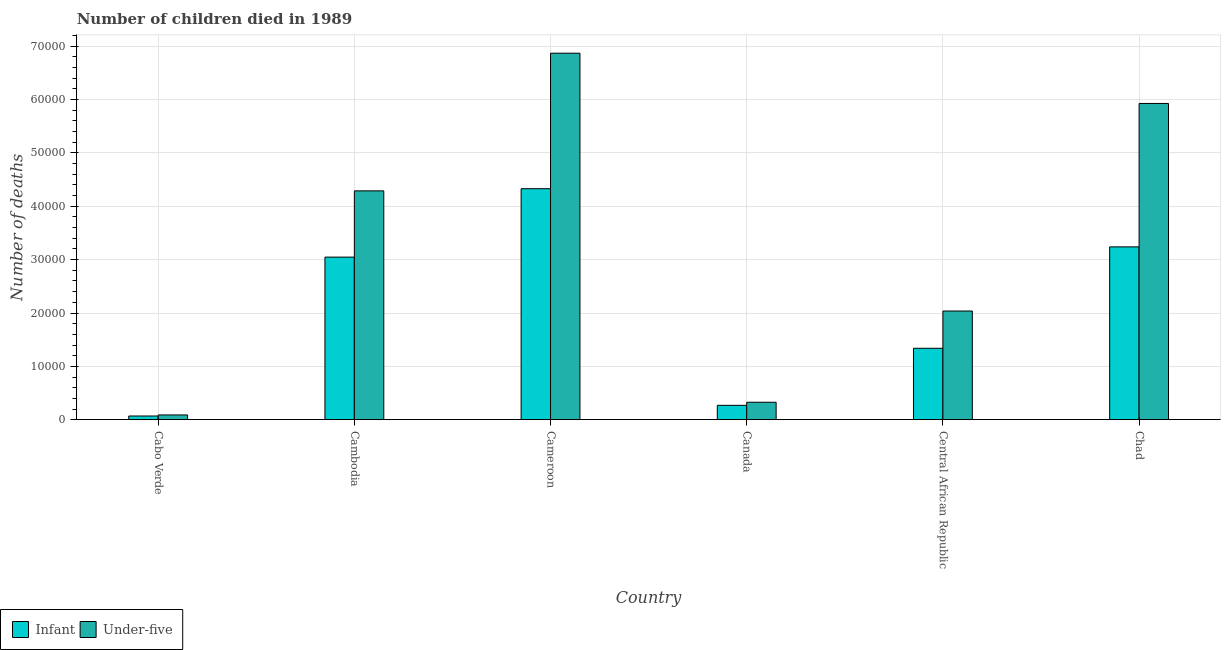How many different coloured bars are there?
Your response must be concise. 2. Are the number of bars per tick equal to the number of legend labels?
Provide a short and direct response. Yes. How many bars are there on the 2nd tick from the left?
Ensure brevity in your answer.  2. How many bars are there on the 2nd tick from the right?
Give a very brief answer. 2. What is the label of the 2nd group of bars from the left?
Your answer should be very brief. Cambodia. In how many cases, is the number of bars for a given country not equal to the number of legend labels?
Make the answer very short. 0. What is the number of under-five deaths in Central African Republic?
Ensure brevity in your answer.  2.04e+04. Across all countries, what is the maximum number of infant deaths?
Your response must be concise. 4.33e+04. Across all countries, what is the minimum number of infant deaths?
Give a very brief answer. 691. In which country was the number of under-five deaths maximum?
Provide a short and direct response. Cameroon. In which country was the number of infant deaths minimum?
Your response must be concise. Cabo Verde. What is the total number of infant deaths in the graph?
Your response must be concise. 1.23e+05. What is the difference between the number of under-five deaths in Canada and that in Chad?
Your response must be concise. -5.60e+04. What is the difference between the number of infant deaths in Chad and the number of under-five deaths in Cabo Verde?
Your response must be concise. 3.15e+04. What is the average number of under-five deaths per country?
Provide a succinct answer. 3.26e+04. What is the difference between the number of infant deaths and number of under-five deaths in Chad?
Your response must be concise. -2.69e+04. What is the ratio of the number of infant deaths in Cambodia to that in Central African Republic?
Ensure brevity in your answer.  2.28. Is the number of infant deaths in Cambodia less than that in Canada?
Ensure brevity in your answer.  No. What is the difference between the highest and the second highest number of infant deaths?
Provide a succinct answer. 1.09e+04. What is the difference between the highest and the lowest number of infant deaths?
Give a very brief answer. 4.26e+04. In how many countries, is the number of infant deaths greater than the average number of infant deaths taken over all countries?
Provide a short and direct response. 3. What does the 1st bar from the left in Cameroon represents?
Offer a very short reply. Infant. What does the 1st bar from the right in Canada represents?
Provide a succinct answer. Under-five. Are all the bars in the graph horizontal?
Ensure brevity in your answer.  No. How many countries are there in the graph?
Your answer should be compact. 6. What is the difference between two consecutive major ticks on the Y-axis?
Provide a succinct answer. 10000. Are the values on the major ticks of Y-axis written in scientific E-notation?
Give a very brief answer. No. Where does the legend appear in the graph?
Your answer should be compact. Bottom left. How are the legend labels stacked?
Provide a short and direct response. Horizontal. What is the title of the graph?
Make the answer very short. Number of children died in 1989. What is the label or title of the X-axis?
Provide a short and direct response. Country. What is the label or title of the Y-axis?
Your response must be concise. Number of deaths. What is the Number of deaths of Infant in Cabo Verde?
Your response must be concise. 691. What is the Number of deaths of Under-five in Cabo Verde?
Make the answer very short. 891. What is the Number of deaths of Infant in Cambodia?
Your response must be concise. 3.05e+04. What is the Number of deaths of Under-five in Cambodia?
Offer a terse response. 4.29e+04. What is the Number of deaths of Infant in Cameroon?
Provide a short and direct response. 4.33e+04. What is the Number of deaths of Under-five in Cameroon?
Make the answer very short. 6.87e+04. What is the Number of deaths in Infant in Canada?
Your answer should be compact. 2692. What is the Number of deaths in Under-five in Canada?
Provide a short and direct response. 3272. What is the Number of deaths in Infant in Central African Republic?
Your response must be concise. 1.34e+04. What is the Number of deaths of Under-five in Central African Republic?
Your response must be concise. 2.04e+04. What is the Number of deaths of Infant in Chad?
Offer a very short reply. 3.24e+04. What is the Number of deaths in Under-five in Chad?
Your answer should be compact. 5.93e+04. Across all countries, what is the maximum Number of deaths of Infant?
Keep it short and to the point. 4.33e+04. Across all countries, what is the maximum Number of deaths in Under-five?
Your response must be concise. 6.87e+04. Across all countries, what is the minimum Number of deaths of Infant?
Offer a terse response. 691. Across all countries, what is the minimum Number of deaths of Under-five?
Your response must be concise. 891. What is the total Number of deaths in Infant in the graph?
Your answer should be compact. 1.23e+05. What is the total Number of deaths in Under-five in the graph?
Your answer should be very brief. 1.95e+05. What is the difference between the Number of deaths of Infant in Cabo Verde and that in Cambodia?
Ensure brevity in your answer.  -2.98e+04. What is the difference between the Number of deaths in Under-five in Cabo Verde and that in Cambodia?
Provide a short and direct response. -4.20e+04. What is the difference between the Number of deaths in Infant in Cabo Verde and that in Cameroon?
Offer a very short reply. -4.26e+04. What is the difference between the Number of deaths in Under-five in Cabo Verde and that in Cameroon?
Your answer should be very brief. -6.78e+04. What is the difference between the Number of deaths in Infant in Cabo Verde and that in Canada?
Provide a short and direct response. -2001. What is the difference between the Number of deaths of Under-five in Cabo Verde and that in Canada?
Offer a terse response. -2381. What is the difference between the Number of deaths in Infant in Cabo Verde and that in Central African Republic?
Provide a succinct answer. -1.27e+04. What is the difference between the Number of deaths in Under-five in Cabo Verde and that in Central African Republic?
Provide a short and direct response. -1.95e+04. What is the difference between the Number of deaths in Infant in Cabo Verde and that in Chad?
Keep it short and to the point. -3.17e+04. What is the difference between the Number of deaths in Under-five in Cabo Verde and that in Chad?
Your answer should be very brief. -5.84e+04. What is the difference between the Number of deaths of Infant in Cambodia and that in Cameroon?
Ensure brevity in your answer.  -1.28e+04. What is the difference between the Number of deaths in Under-five in Cambodia and that in Cameroon?
Provide a succinct answer. -2.58e+04. What is the difference between the Number of deaths in Infant in Cambodia and that in Canada?
Your answer should be compact. 2.78e+04. What is the difference between the Number of deaths in Under-five in Cambodia and that in Canada?
Give a very brief answer. 3.96e+04. What is the difference between the Number of deaths in Infant in Cambodia and that in Central African Republic?
Your answer should be very brief. 1.71e+04. What is the difference between the Number of deaths in Under-five in Cambodia and that in Central African Republic?
Provide a short and direct response. 2.25e+04. What is the difference between the Number of deaths in Infant in Cambodia and that in Chad?
Offer a very short reply. -1920. What is the difference between the Number of deaths of Under-five in Cambodia and that in Chad?
Keep it short and to the point. -1.64e+04. What is the difference between the Number of deaths in Infant in Cameroon and that in Canada?
Ensure brevity in your answer.  4.06e+04. What is the difference between the Number of deaths in Under-five in Cameroon and that in Canada?
Offer a terse response. 6.54e+04. What is the difference between the Number of deaths in Infant in Cameroon and that in Central African Republic?
Your answer should be very brief. 2.99e+04. What is the difference between the Number of deaths of Under-five in Cameroon and that in Central African Republic?
Keep it short and to the point. 4.83e+04. What is the difference between the Number of deaths in Infant in Cameroon and that in Chad?
Offer a terse response. 1.09e+04. What is the difference between the Number of deaths of Under-five in Cameroon and that in Chad?
Provide a short and direct response. 9421. What is the difference between the Number of deaths in Infant in Canada and that in Central African Republic?
Provide a succinct answer. -1.07e+04. What is the difference between the Number of deaths in Under-five in Canada and that in Central African Republic?
Offer a terse response. -1.71e+04. What is the difference between the Number of deaths in Infant in Canada and that in Chad?
Make the answer very short. -2.97e+04. What is the difference between the Number of deaths of Under-five in Canada and that in Chad?
Ensure brevity in your answer.  -5.60e+04. What is the difference between the Number of deaths in Infant in Central African Republic and that in Chad?
Give a very brief answer. -1.90e+04. What is the difference between the Number of deaths of Under-five in Central African Republic and that in Chad?
Ensure brevity in your answer.  -3.89e+04. What is the difference between the Number of deaths in Infant in Cabo Verde and the Number of deaths in Under-five in Cambodia?
Offer a terse response. -4.22e+04. What is the difference between the Number of deaths in Infant in Cabo Verde and the Number of deaths in Under-five in Cameroon?
Ensure brevity in your answer.  -6.80e+04. What is the difference between the Number of deaths of Infant in Cabo Verde and the Number of deaths of Under-five in Canada?
Ensure brevity in your answer.  -2581. What is the difference between the Number of deaths of Infant in Cabo Verde and the Number of deaths of Under-five in Central African Republic?
Keep it short and to the point. -1.97e+04. What is the difference between the Number of deaths in Infant in Cabo Verde and the Number of deaths in Under-five in Chad?
Provide a succinct answer. -5.86e+04. What is the difference between the Number of deaths in Infant in Cambodia and the Number of deaths in Under-five in Cameroon?
Offer a very short reply. -3.82e+04. What is the difference between the Number of deaths in Infant in Cambodia and the Number of deaths in Under-five in Canada?
Your answer should be very brief. 2.72e+04. What is the difference between the Number of deaths in Infant in Cambodia and the Number of deaths in Under-five in Central African Republic?
Provide a short and direct response. 1.01e+04. What is the difference between the Number of deaths of Infant in Cambodia and the Number of deaths of Under-five in Chad?
Provide a short and direct response. -2.88e+04. What is the difference between the Number of deaths in Infant in Cameroon and the Number of deaths in Under-five in Canada?
Offer a very short reply. 4.00e+04. What is the difference between the Number of deaths of Infant in Cameroon and the Number of deaths of Under-five in Central African Republic?
Ensure brevity in your answer.  2.29e+04. What is the difference between the Number of deaths of Infant in Cameroon and the Number of deaths of Under-five in Chad?
Provide a succinct answer. -1.60e+04. What is the difference between the Number of deaths in Infant in Canada and the Number of deaths in Under-five in Central African Republic?
Offer a very short reply. -1.77e+04. What is the difference between the Number of deaths in Infant in Canada and the Number of deaths in Under-five in Chad?
Provide a short and direct response. -5.66e+04. What is the difference between the Number of deaths in Infant in Central African Republic and the Number of deaths in Under-five in Chad?
Provide a short and direct response. -4.59e+04. What is the average Number of deaths in Infant per country?
Give a very brief answer. 2.05e+04. What is the average Number of deaths in Under-five per country?
Your answer should be very brief. 3.26e+04. What is the difference between the Number of deaths of Infant and Number of deaths of Under-five in Cabo Verde?
Give a very brief answer. -200. What is the difference between the Number of deaths in Infant and Number of deaths in Under-five in Cambodia?
Provide a succinct answer. -1.24e+04. What is the difference between the Number of deaths of Infant and Number of deaths of Under-five in Cameroon?
Your answer should be very brief. -2.54e+04. What is the difference between the Number of deaths of Infant and Number of deaths of Under-five in Canada?
Your answer should be compact. -580. What is the difference between the Number of deaths in Infant and Number of deaths in Under-five in Central African Republic?
Offer a very short reply. -6981. What is the difference between the Number of deaths of Infant and Number of deaths of Under-five in Chad?
Your answer should be very brief. -2.69e+04. What is the ratio of the Number of deaths in Infant in Cabo Verde to that in Cambodia?
Offer a very short reply. 0.02. What is the ratio of the Number of deaths of Under-five in Cabo Verde to that in Cambodia?
Make the answer very short. 0.02. What is the ratio of the Number of deaths of Infant in Cabo Verde to that in Cameroon?
Offer a very short reply. 0.02. What is the ratio of the Number of deaths in Under-five in Cabo Verde to that in Cameroon?
Make the answer very short. 0.01. What is the ratio of the Number of deaths of Infant in Cabo Verde to that in Canada?
Provide a short and direct response. 0.26. What is the ratio of the Number of deaths of Under-five in Cabo Verde to that in Canada?
Your answer should be very brief. 0.27. What is the ratio of the Number of deaths of Infant in Cabo Verde to that in Central African Republic?
Provide a succinct answer. 0.05. What is the ratio of the Number of deaths of Under-five in Cabo Verde to that in Central African Republic?
Give a very brief answer. 0.04. What is the ratio of the Number of deaths in Infant in Cabo Verde to that in Chad?
Make the answer very short. 0.02. What is the ratio of the Number of deaths in Under-five in Cabo Verde to that in Chad?
Provide a succinct answer. 0.01. What is the ratio of the Number of deaths of Infant in Cambodia to that in Cameroon?
Your answer should be compact. 0.7. What is the ratio of the Number of deaths in Under-five in Cambodia to that in Cameroon?
Provide a short and direct response. 0.62. What is the ratio of the Number of deaths of Infant in Cambodia to that in Canada?
Make the answer very short. 11.32. What is the ratio of the Number of deaths of Under-five in Cambodia to that in Canada?
Offer a very short reply. 13.11. What is the ratio of the Number of deaths in Infant in Cambodia to that in Central African Republic?
Give a very brief answer. 2.28. What is the ratio of the Number of deaths of Under-five in Cambodia to that in Central African Republic?
Offer a terse response. 2.11. What is the ratio of the Number of deaths of Infant in Cambodia to that in Chad?
Make the answer very short. 0.94. What is the ratio of the Number of deaths in Under-five in Cambodia to that in Chad?
Ensure brevity in your answer.  0.72. What is the ratio of the Number of deaths of Infant in Cameroon to that in Canada?
Provide a short and direct response. 16.08. What is the ratio of the Number of deaths of Under-five in Cameroon to that in Canada?
Keep it short and to the point. 21. What is the ratio of the Number of deaths in Infant in Cameroon to that in Central African Republic?
Give a very brief answer. 3.23. What is the ratio of the Number of deaths in Under-five in Cameroon to that in Central African Republic?
Provide a short and direct response. 3.37. What is the ratio of the Number of deaths in Infant in Cameroon to that in Chad?
Offer a terse response. 1.34. What is the ratio of the Number of deaths of Under-five in Cameroon to that in Chad?
Provide a succinct answer. 1.16. What is the ratio of the Number of deaths of Infant in Canada to that in Central African Republic?
Ensure brevity in your answer.  0.2. What is the ratio of the Number of deaths of Under-five in Canada to that in Central African Republic?
Make the answer very short. 0.16. What is the ratio of the Number of deaths in Infant in Canada to that in Chad?
Your answer should be very brief. 0.08. What is the ratio of the Number of deaths in Under-five in Canada to that in Chad?
Offer a terse response. 0.06. What is the ratio of the Number of deaths in Infant in Central African Republic to that in Chad?
Make the answer very short. 0.41. What is the ratio of the Number of deaths of Under-five in Central African Republic to that in Chad?
Your response must be concise. 0.34. What is the difference between the highest and the second highest Number of deaths of Infant?
Your answer should be very brief. 1.09e+04. What is the difference between the highest and the second highest Number of deaths in Under-five?
Provide a short and direct response. 9421. What is the difference between the highest and the lowest Number of deaths in Infant?
Offer a very short reply. 4.26e+04. What is the difference between the highest and the lowest Number of deaths in Under-five?
Offer a terse response. 6.78e+04. 